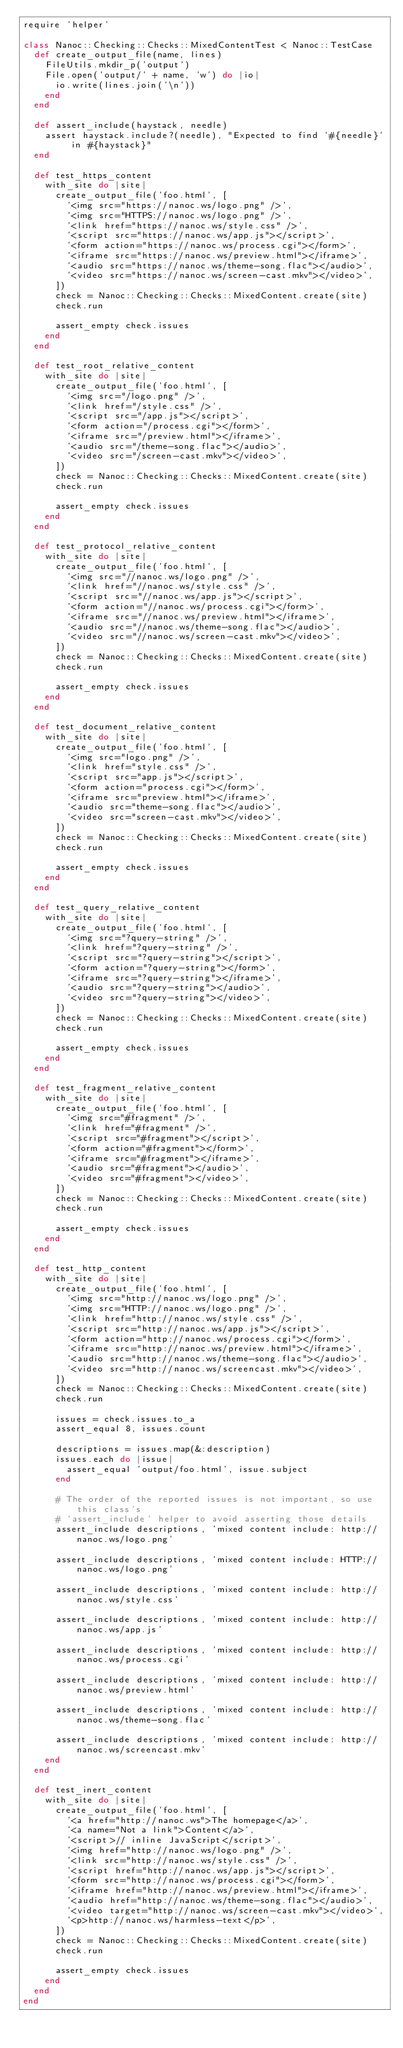Convert code to text. <code><loc_0><loc_0><loc_500><loc_500><_Ruby_>require 'helper'

class Nanoc::Checking::Checks::MixedContentTest < Nanoc::TestCase
  def create_output_file(name, lines)
    FileUtils.mkdir_p('output')
    File.open('output/' + name, 'w') do |io|
      io.write(lines.join('\n'))
    end
  end

  def assert_include(haystack, needle)
    assert haystack.include?(needle), "Expected to find '#{needle}' in #{haystack}"
  end

  def test_https_content
    with_site do |site|
      create_output_file('foo.html', [
        '<img src="https://nanoc.ws/logo.png" />',
        '<img src="HTTPS://nanoc.ws/logo.png" />',
        '<link href="https://nanoc.ws/style.css" />',
        '<script src="https://nanoc.ws/app.js"></script>',
        '<form action="https://nanoc.ws/process.cgi"></form>',
        '<iframe src="https://nanoc.ws/preview.html"></iframe>',
        '<audio src="https://nanoc.ws/theme-song.flac"></audio>',
        '<video src="https://nanoc.ws/screen-cast.mkv"></video>',
      ])
      check = Nanoc::Checking::Checks::MixedContent.create(site)
      check.run

      assert_empty check.issues
    end
  end

  def test_root_relative_content
    with_site do |site|
      create_output_file('foo.html', [
        '<img src="/logo.png" />',
        '<link href="/style.css" />',
        '<script src="/app.js"></script>',
        '<form action="/process.cgi"></form>',
        '<iframe src="/preview.html"></iframe>',
        '<audio src="/theme-song.flac"></audio>',
        '<video src="/screen-cast.mkv"></video>',
      ])
      check = Nanoc::Checking::Checks::MixedContent.create(site)
      check.run

      assert_empty check.issues
    end
  end

  def test_protocol_relative_content
    with_site do |site|
      create_output_file('foo.html', [
        '<img src="//nanoc.ws/logo.png" />',
        '<link href="//nanoc.ws/style.css" />',
        '<script src="//nanoc.ws/app.js"></script>',
        '<form action="//nanoc.ws/process.cgi"></form>',
        '<iframe src="//nanoc.ws/preview.html"></iframe>',
        '<audio src="//nanoc.ws/theme-song.flac"></audio>',
        '<video src="//nanoc.ws/screen-cast.mkv"></video>',
      ])
      check = Nanoc::Checking::Checks::MixedContent.create(site)
      check.run

      assert_empty check.issues
    end
  end

  def test_document_relative_content
    with_site do |site|
      create_output_file('foo.html', [
        '<img src="logo.png" />',
        '<link href="style.css" />',
        '<script src="app.js"></script>',
        '<form action="process.cgi"></form>',
        '<iframe src="preview.html"></iframe>',
        '<audio src="theme-song.flac"></audio>',
        '<video src="screen-cast.mkv"></video>',
      ])
      check = Nanoc::Checking::Checks::MixedContent.create(site)
      check.run

      assert_empty check.issues
    end
  end

  def test_query_relative_content
    with_site do |site|
      create_output_file('foo.html', [
        '<img src="?query-string" />',
        '<link href="?query-string" />',
        '<script src="?query-string"></script>',
        '<form action="?query-string"></form>',
        '<iframe src="?query-string"></iframe>',
        '<audio src="?query-string"></audio>',
        '<video src="?query-string"></video>',
      ])
      check = Nanoc::Checking::Checks::MixedContent.create(site)
      check.run

      assert_empty check.issues
    end
  end

  def test_fragment_relative_content
    with_site do |site|
      create_output_file('foo.html', [
        '<img src="#fragment" />',
        '<link href="#fragment" />',
        '<script src="#fragment"></script>',
        '<form action="#fragment"></form>',
        '<iframe src="#fragment"></iframe>',
        '<audio src="#fragment"></audio>',
        '<video src="#fragment"></video>',
      ])
      check = Nanoc::Checking::Checks::MixedContent.create(site)
      check.run

      assert_empty check.issues
    end
  end

  def test_http_content
    with_site do |site|
      create_output_file('foo.html', [
        '<img src="http://nanoc.ws/logo.png" />',
        '<img src="HTTP://nanoc.ws/logo.png" />',
        '<link href="http://nanoc.ws/style.css" />',
        '<script src="http://nanoc.ws/app.js"></script>',
        '<form action="http://nanoc.ws/process.cgi"></form>',
        '<iframe src="http://nanoc.ws/preview.html"></iframe>',
        '<audio src="http://nanoc.ws/theme-song.flac"></audio>',
        '<video src="http://nanoc.ws/screencast.mkv"></video>',
      ])
      check = Nanoc::Checking::Checks::MixedContent.create(site)
      check.run

      issues = check.issues.to_a
      assert_equal 8, issues.count

      descriptions = issues.map(&:description)
      issues.each do |issue|
        assert_equal 'output/foo.html', issue.subject
      end

      # The order of the reported issues is not important, so use this class's
      # `assert_include` helper to avoid asserting those details
      assert_include descriptions, 'mixed content include: http://nanoc.ws/logo.png'

      assert_include descriptions, 'mixed content include: HTTP://nanoc.ws/logo.png'

      assert_include descriptions, 'mixed content include: http://nanoc.ws/style.css'

      assert_include descriptions, 'mixed content include: http://nanoc.ws/app.js'

      assert_include descriptions, 'mixed content include: http://nanoc.ws/process.cgi'

      assert_include descriptions, 'mixed content include: http://nanoc.ws/preview.html'

      assert_include descriptions, 'mixed content include: http://nanoc.ws/theme-song.flac'

      assert_include descriptions, 'mixed content include: http://nanoc.ws/screencast.mkv'
    end
  end

  def test_inert_content
    with_site do |site|
      create_output_file('foo.html', [
        '<a href="http://nanoc.ws">The homepage</a>',
        '<a name="Not a link">Content</a>',
        '<script>// inline JavaScript</script>',
        '<img href="http://nanoc.ws/logo.png" />',
        '<link src="http://nanoc.ws/style.css" />',
        '<script href="http://nanoc.ws/app.js"></script>',
        '<form src="http://nanoc.ws/process.cgi"></form>',
        '<iframe href="http://nanoc.ws/preview.html"></iframe>',
        '<audio href="http://nanoc.ws/theme-song.flac"></audio>',
        '<video target="http://nanoc.ws/screen-cast.mkv"></video>',
        '<p>http://nanoc.ws/harmless-text</p>',
      ])
      check = Nanoc::Checking::Checks::MixedContent.create(site)
      check.run

      assert_empty check.issues
    end
  end
end
</code> 